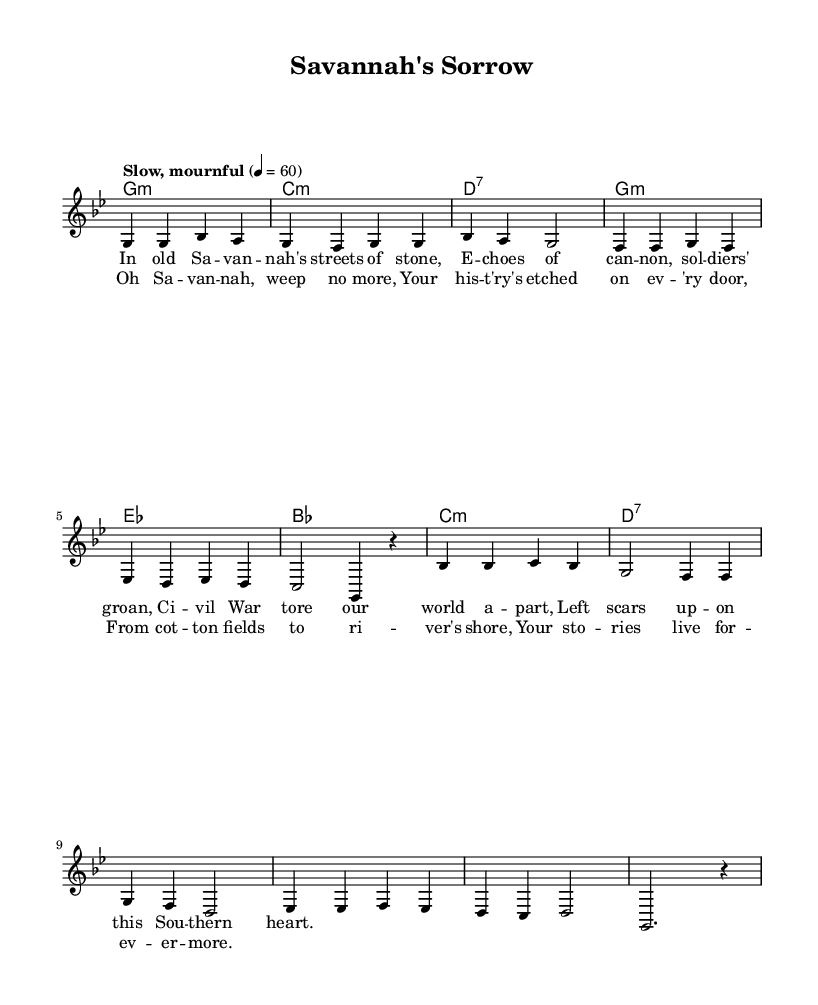What is the key signature of this music? The key signature is G minor, which has two flats (B flat and E flat). This can be inferred from the global settings at the top of the sheet music where it states \key g \minor.
Answer: G minor What is the time signature of this music? The time signature is 4/4, indicated in the global settings section with \time 4/4. This means there are four beats per measure.
Answer: 4/4 What is the tempo marking for this piece? The tempo marking is "Slow, mournful," which can be found just below the global settings. It indicates the intended speed and mood of the performance.
Answer: Slow, mournful How many verses are present in the music? There is one verse provided, as seen in the lyrics section. The verse lyrics are under the "lead" voice part, and it is labeled distinctly.
Answer: One What is the structure of the song? The structure consists of a verse followed by a chorus, as indicated by the distinct labeling of the lyrics sections and the arrangement of music that alternates between these two parts.
Answer: Verse, Chorus What chord comes after the first line of the chorus? The chord after the first line of the chorus is G. By analyzing the chord progression listed under the harmonies, this can be determined.
Answer: G What themes does the song's lyrics hint at? The themes hint at nostalgia, loss, and history, particularly relating to the Civil War and its scars in Savannah. This can be inferred from the content of both the verse and chorus.
Answer: Nostalgia, loss, history 